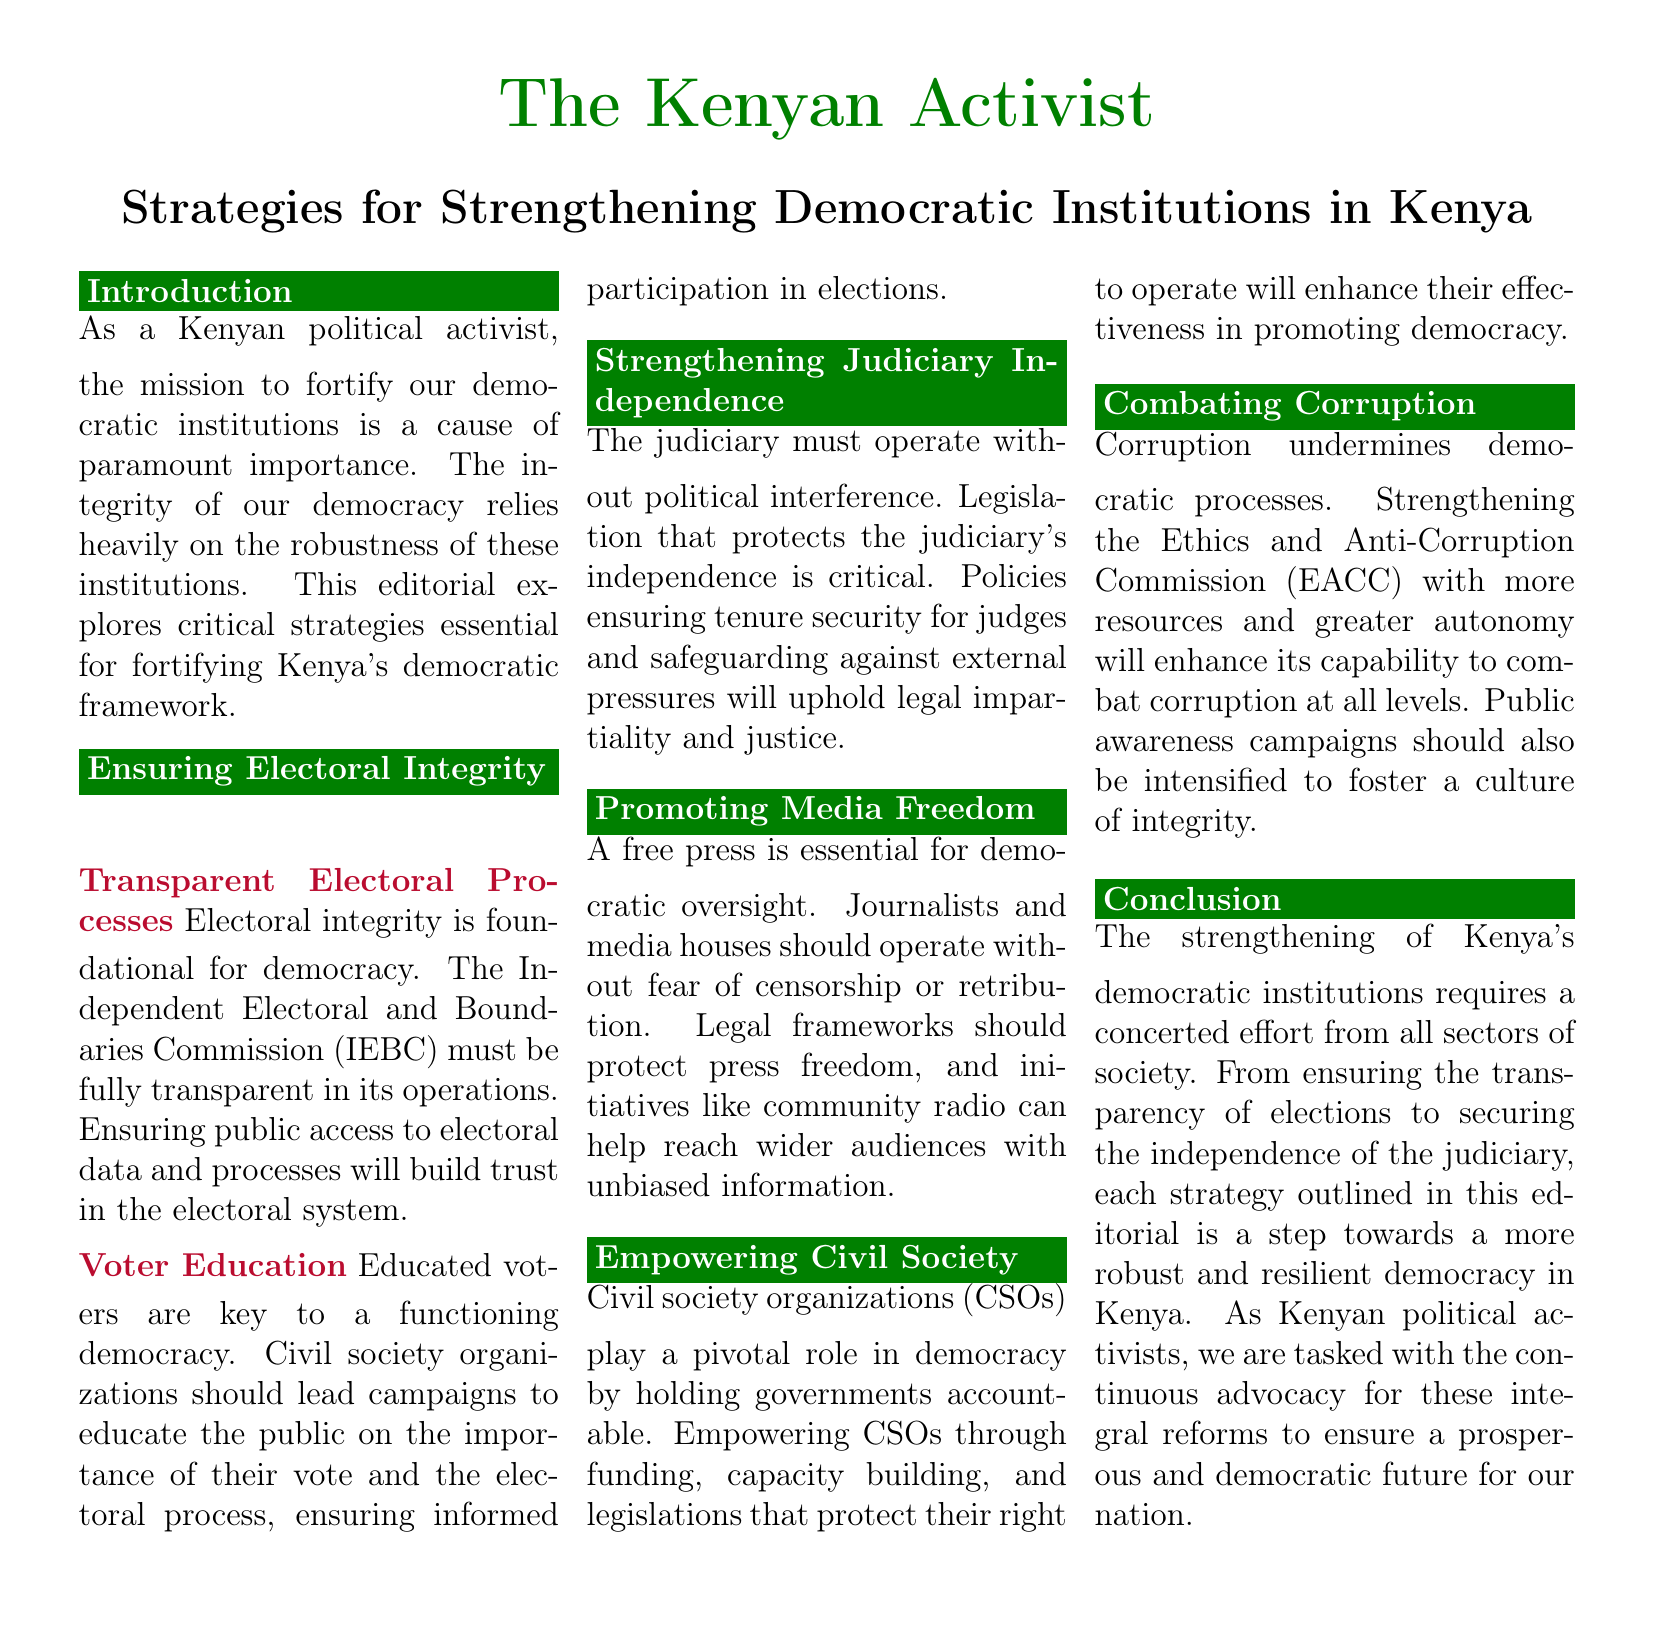What is the title of the editorial? The title of the editorial is the main heading presented at the top of the document.
Answer: Strategies for Strengthening Democratic Institutions in Kenya Who is primarily responsible for ensuring electoral integrity in Kenya? The Independent Electoral and Boundaries Commission (IEBC) is specified as responsible for this in the editorial.
Answer: IEBC What is essential for a functioning democracy according to the document? The document states that educated voters are key to a functioning democracy.
Answer: Educated voters What aspect of civil society organizations is highlighted in the editorial? The editorial emphasizes that CSOs play a pivotal role in holding governments accountable.
Answer: Accountability What is one suggested way to combat corruption in Kenya? The document suggests strengthening the Ethics and Anti-Corruption Commission (EACC) for combating corruption.
Answer: Strengthening EACC Which type of media is recommended to help reach wider audiences with unbiased information? The editorial mentions community radio as a recommended type of media.
Answer: Community radio What must the judiciary operate without according to the document? The document specifies that the judiciary must operate without political interference.
Answer: Political interference What is the desired outcome of strengthening democracy according to the conclusion? The conclusion states that the aim is a more robust and resilient democracy in Kenya.
Answer: Robust and resilient democracy 